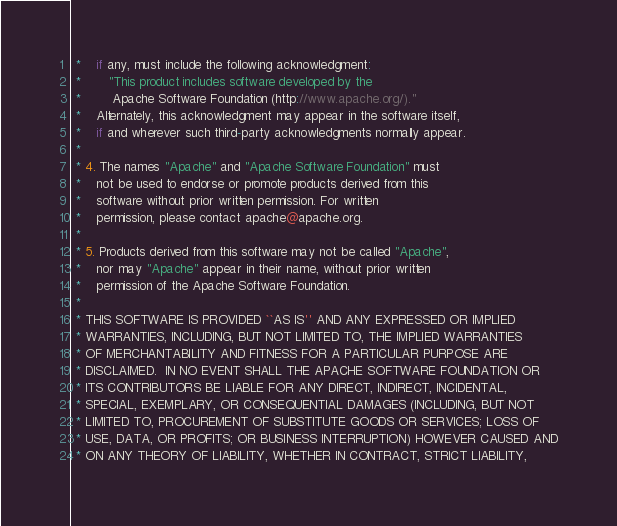Convert code to text. <code><loc_0><loc_0><loc_500><loc_500><_C_> *    if any, must include the following acknowledgment:
 *       "This product includes software developed by the
 *        Apache Software Foundation (http://www.apache.org/)."
 *    Alternately, this acknowledgment may appear in the software itself,
 *    if and wherever such third-party acknowledgments normally appear.
 *
 * 4. The names "Apache" and "Apache Software Foundation" must
 *    not be used to endorse or promote products derived from this
 *    software without prior written permission. For written
 *    permission, please contact apache@apache.org.
 *
 * 5. Products derived from this software may not be called "Apache",
 *    nor may "Apache" appear in their name, without prior written
 *    permission of the Apache Software Foundation.
 *
 * THIS SOFTWARE IS PROVIDED ``AS IS'' AND ANY EXPRESSED OR IMPLIED
 * WARRANTIES, INCLUDING, BUT NOT LIMITED TO, THE IMPLIED WARRANTIES
 * OF MERCHANTABILITY AND FITNESS FOR A PARTICULAR PURPOSE ARE
 * DISCLAIMED.  IN NO EVENT SHALL THE APACHE SOFTWARE FOUNDATION OR
 * ITS CONTRIBUTORS BE LIABLE FOR ANY DIRECT, INDIRECT, INCIDENTAL,
 * SPECIAL, EXEMPLARY, OR CONSEQUENTIAL DAMAGES (INCLUDING, BUT NOT
 * LIMITED TO, PROCUREMENT OF SUBSTITUTE GOODS OR SERVICES; LOSS OF
 * USE, DATA, OR PROFITS; OR BUSINESS INTERRUPTION) HOWEVER CAUSED AND
 * ON ANY THEORY OF LIABILITY, WHETHER IN CONTRACT, STRICT LIABILITY,</code> 